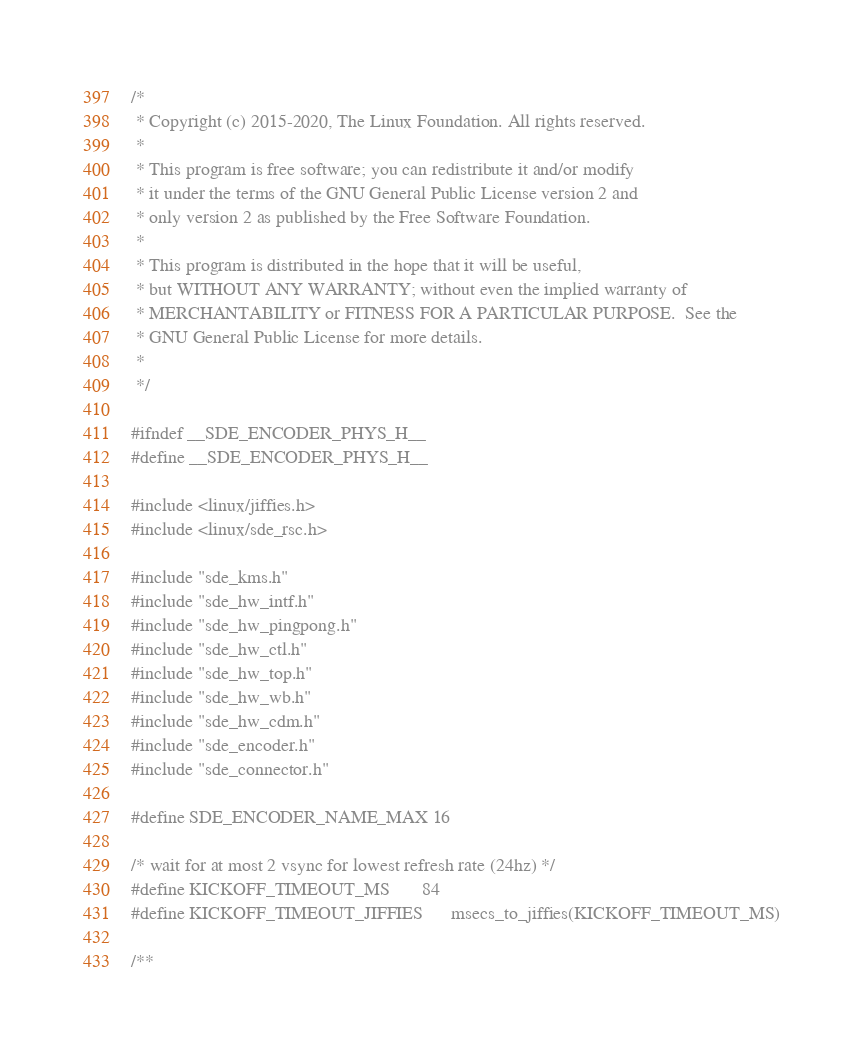Convert code to text. <code><loc_0><loc_0><loc_500><loc_500><_C_>/*
 * Copyright (c) 2015-2020, The Linux Foundation. All rights reserved.
 *
 * This program is free software; you can redistribute it and/or modify
 * it under the terms of the GNU General Public License version 2 and
 * only version 2 as published by the Free Software Foundation.
 *
 * This program is distributed in the hope that it will be useful,
 * but WITHOUT ANY WARRANTY; without even the implied warranty of
 * MERCHANTABILITY or FITNESS FOR A PARTICULAR PURPOSE.  See the
 * GNU General Public License for more details.
 *
 */

#ifndef __SDE_ENCODER_PHYS_H__
#define __SDE_ENCODER_PHYS_H__

#include <linux/jiffies.h>
#include <linux/sde_rsc.h>

#include "sde_kms.h"
#include "sde_hw_intf.h"
#include "sde_hw_pingpong.h"
#include "sde_hw_ctl.h"
#include "sde_hw_top.h"
#include "sde_hw_wb.h"
#include "sde_hw_cdm.h"
#include "sde_encoder.h"
#include "sde_connector.h"

#define SDE_ENCODER_NAME_MAX	16

/* wait for at most 2 vsync for lowest refresh rate (24hz) */
#define KICKOFF_TIMEOUT_MS		84
#define KICKOFF_TIMEOUT_JIFFIES		msecs_to_jiffies(KICKOFF_TIMEOUT_MS)

/**</code> 